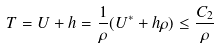Convert formula to latex. <formula><loc_0><loc_0><loc_500><loc_500>T = U + h = \frac { 1 } { \rho } ( U ^ { \ast } + h \rho ) \leq \frac { C _ { 2 } } { \rho }</formula> 